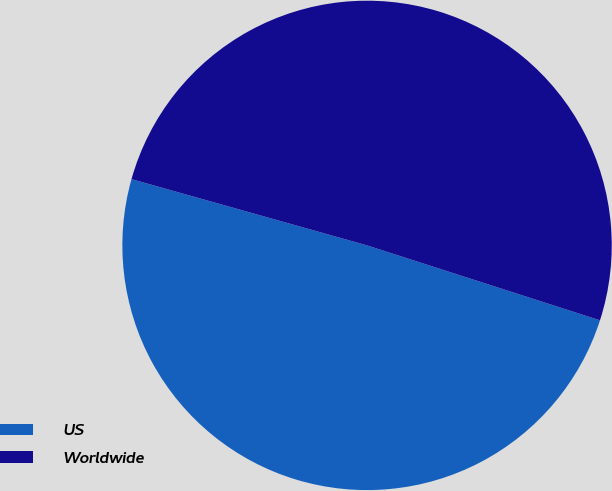<chart> <loc_0><loc_0><loc_500><loc_500><pie_chart><fcel>US<fcel>Worldwide<nl><fcel>49.41%<fcel>50.59%<nl></chart> 